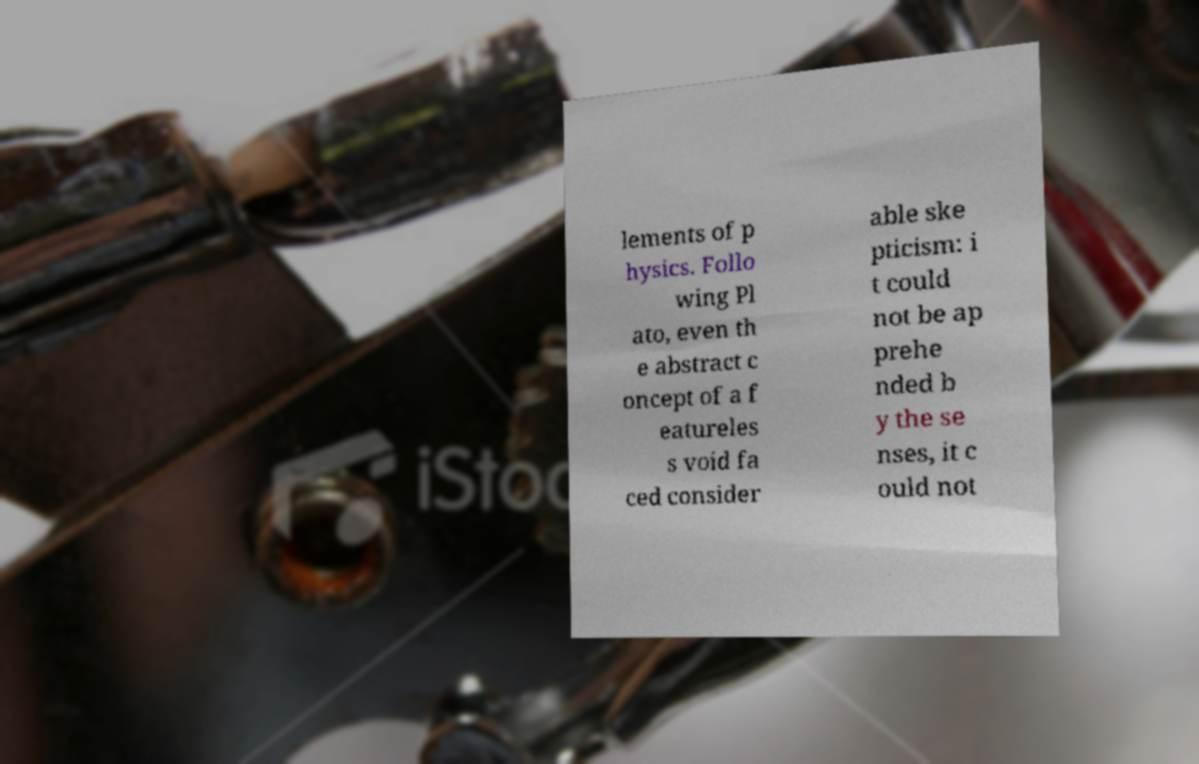Can you accurately transcribe the text from the provided image for me? lements of p hysics. Follo wing Pl ato, even th e abstract c oncept of a f eatureles s void fa ced consider able ske pticism: i t could not be ap prehe nded b y the se nses, it c ould not 